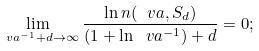Convert formula to latex. <formula><loc_0><loc_0><loc_500><loc_500>\lim _ { \ v a ^ { - 1 } + d \rightarrow \infty } \frac { \ln n ( \ v a , S _ { d } ) } { ( 1 + \ln \ v a ^ { - 1 } ) + d } = 0 ;</formula> 